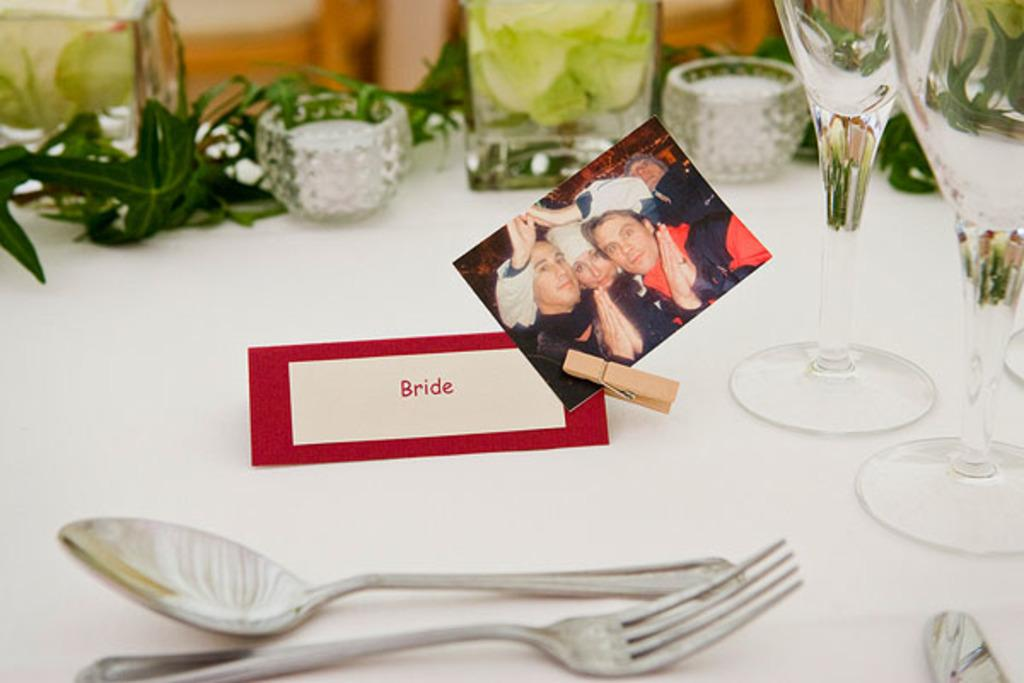What type of furniture is in the image? There is a table in the image. What can be seen on the table? A card with the word "bride" written on it, a photo, a spoon, a fork, a knife, a glass, and leaves are visible on the table. What might be used for cutting in the image? A knife is visible on the table. What might be used for drinking in the image? A glass is visible on the table. What type of record can be seen spinning on the table in the image? There is no record present in the image; only a card, photo, utensils, glass, and leaves are visible on the table. What shape is the fish that is swimming in the image? There is no fish present in the image. 